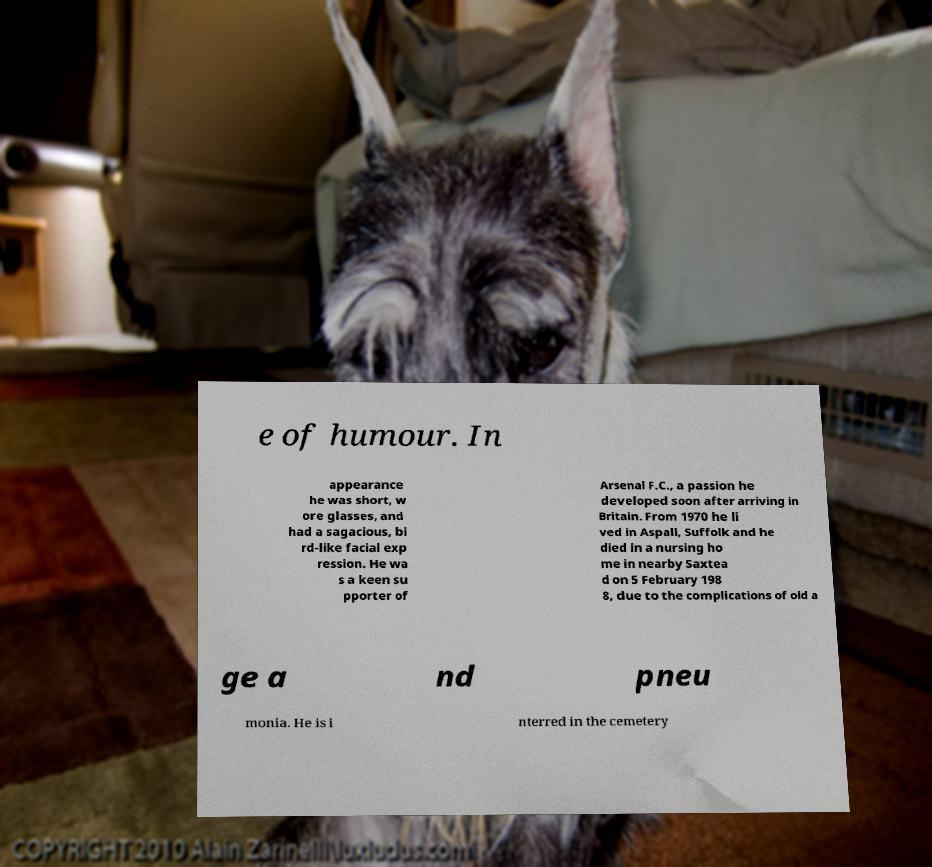There's text embedded in this image that I need extracted. Can you transcribe it verbatim? e of humour. In appearance he was short, w ore glasses, and had a sagacious, bi rd-like facial exp ression. He wa s a keen su pporter of Arsenal F.C., a passion he developed soon after arriving in Britain. From 1970 he li ved in Aspall, Suffolk and he died in a nursing ho me in nearby Saxtea d on 5 February 198 8, due to the complications of old a ge a nd pneu monia. He is i nterred in the cemetery 